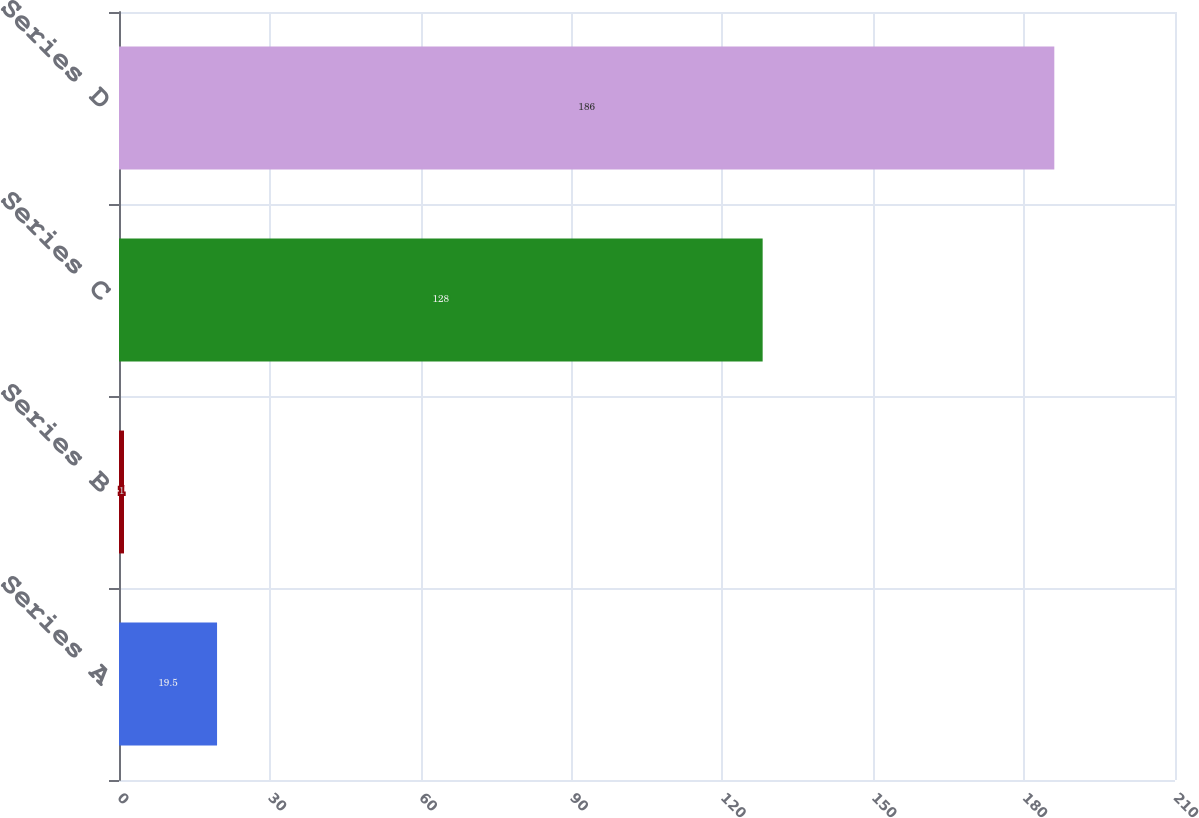<chart> <loc_0><loc_0><loc_500><loc_500><bar_chart><fcel>Series A<fcel>Series B<fcel>Series C<fcel>Series D<nl><fcel>19.5<fcel>1<fcel>128<fcel>186<nl></chart> 